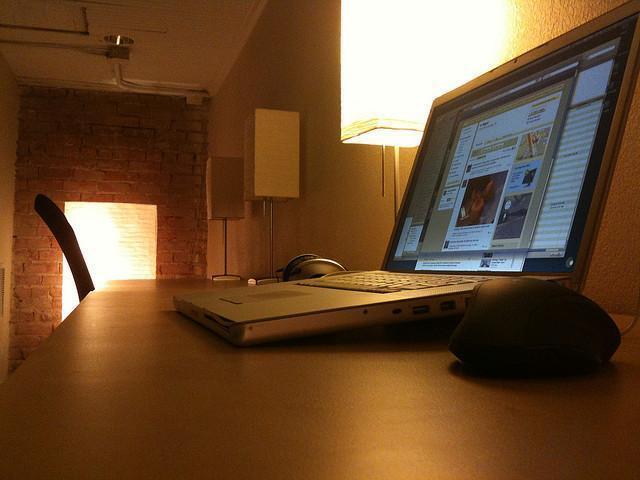How many laptops are in the photo?
Give a very brief answer. 1. 